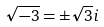Convert formula to latex. <formula><loc_0><loc_0><loc_500><loc_500>\sqrt { - 3 } = \pm \sqrt { 3 } i</formula> 